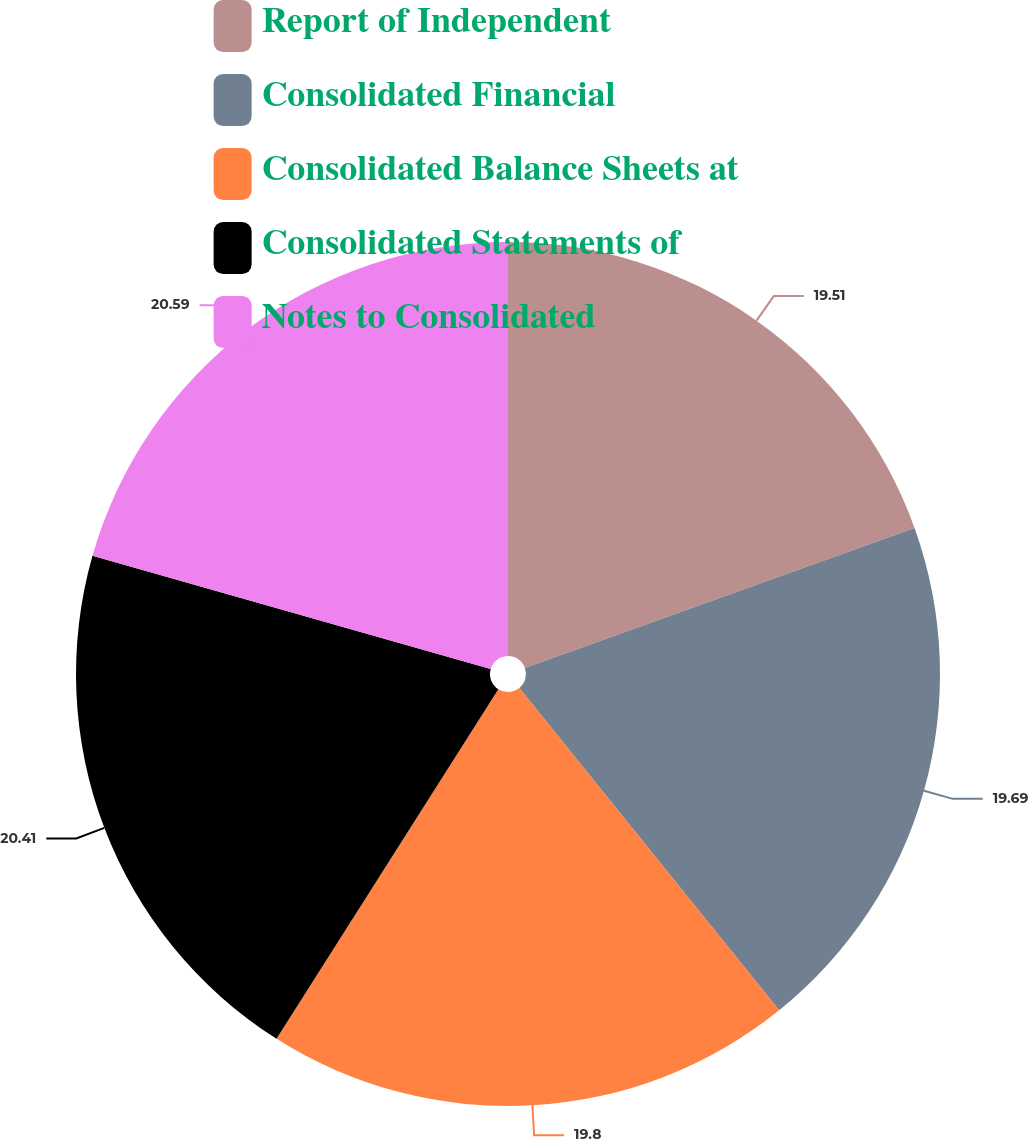<chart> <loc_0><loc_0><loc_500><loc_500><pie_chart><fcel>Report of Independent<fcel>Consolidated Financial<fcel>Consolidated Balance Sheets at<fcel>Consolidated Statements of<fcel>Notes to Consolidated<nl><fcel>19.51%<fcel>19.69%<fcel>19.8%<fcel>20.41%<fcel>20.59%<nl></chart> 